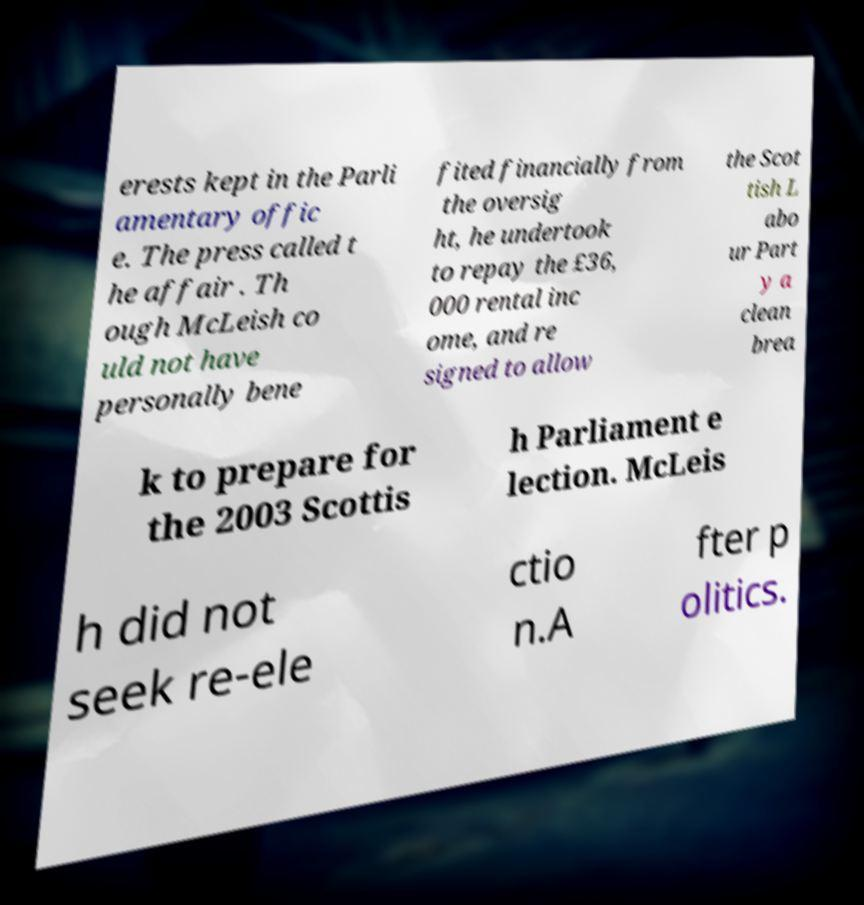Could you extract and type out the text from this image? erests kept in the Parli amentary offic e. The press called t he affair . Th ough McLeish co uld not have personally bene fited financially from the oversig ht, he undertook to repay the £36, 000 rental inc ome, and re signed to allow the Scot tish L abo ur Part y a clean brea k to prepare for the 2003 Scottis h Parliament e lection. McLeis h did not seek re-ele ctio n.A fter p olitics. 